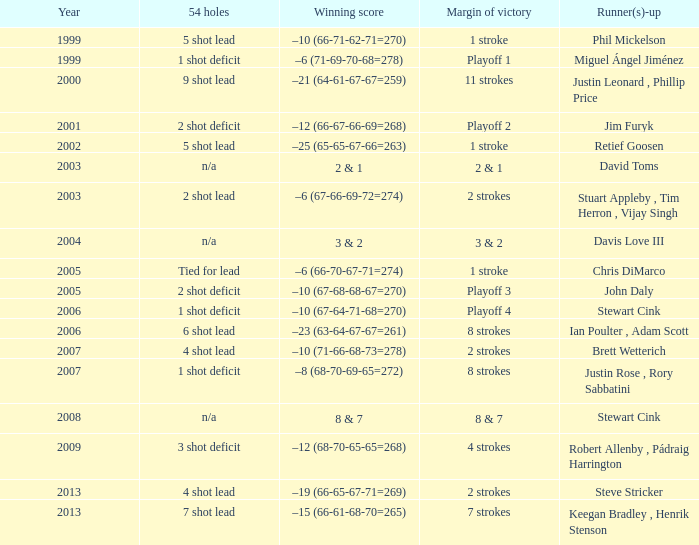In which year did steve stricker reach his peak as a second-place finisher? 2013.0. 